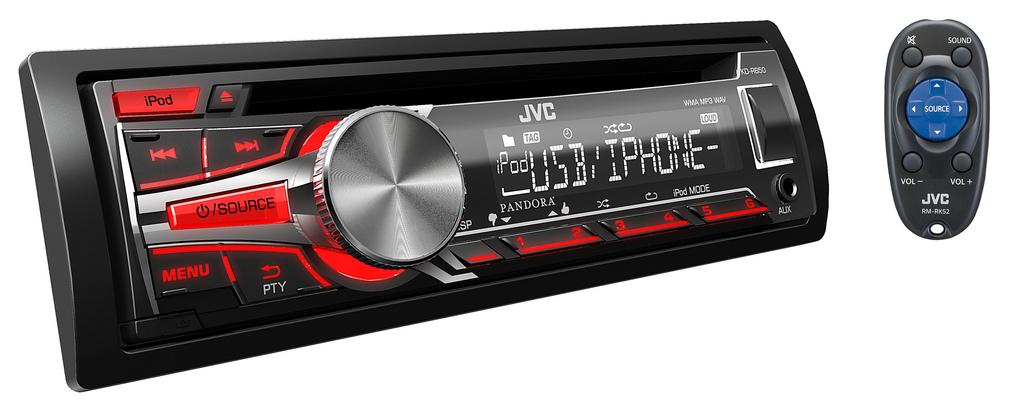<image>
Present a compact description of the photo's key features. A JVC car radio that can synch to an iPod and has a small remote control. 